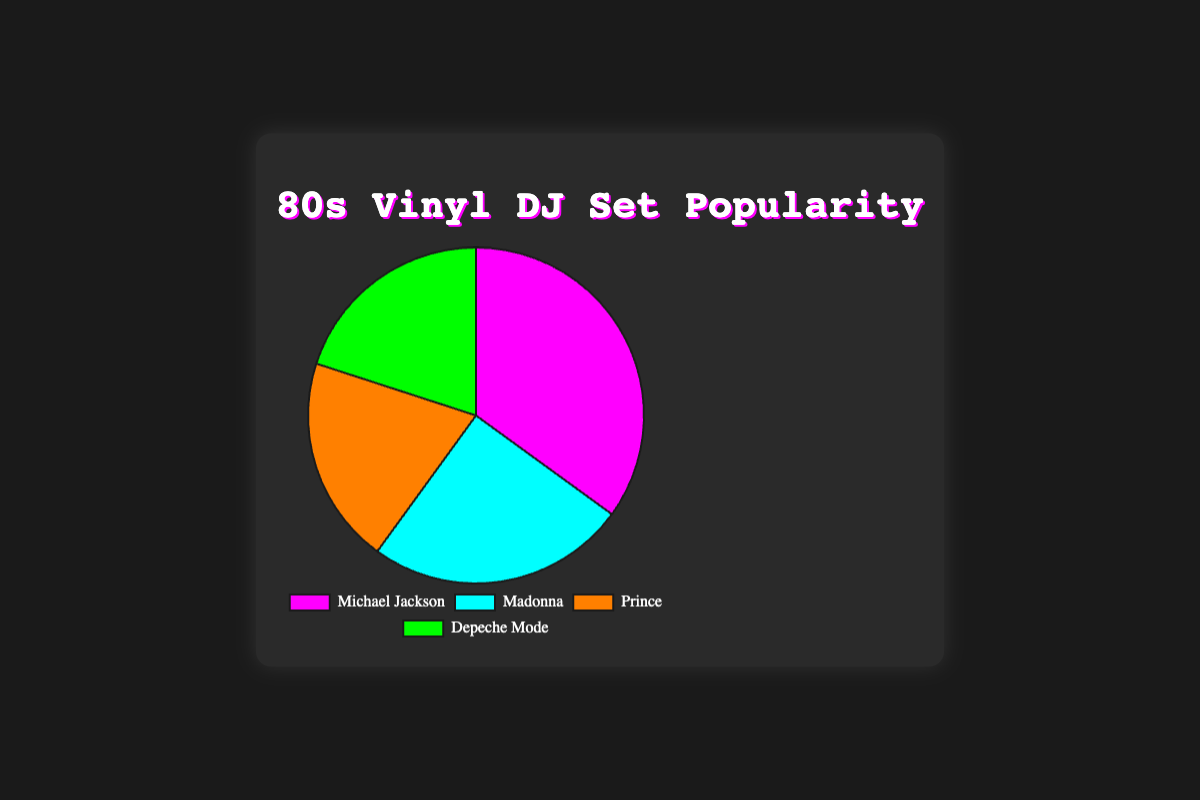Which artist appears most frequently in the DJ sets? By looking at the pie chart, Michael Jackson holds the largest section with 35 sets, which is the highest among the artists.
Answer: Michael Jackson Which artist appears least frequently in the DJ sets? Both Prince and Depeche Mode have the smallest sections in the pie chart, each with 20 sets.
Answer: Prince and Depeche Mode What is the total number of DJ sets represented in the pie chart? To get the total count, sum the sets of all artists: 35 (Michael Jackson) + 25 (Madonna) + 20 (Prince) + 20 (Depeche Mode) = 100 sets.
Answer: 100 How many more DJ sets does Michael Jackson have compared to Prince? Michael Jackson has 35 sets, and Prince has 20 sets. The difference is 35 - 20 = 15 sets.
Answer: 15 What is the average number of DJ sets per artist? The total number of sets is 100. There are 4 artists, so the average is 100 / 4 = 25 sets per artist.
Answer: 25 Which artist has a section colored in blue? By referring to the pie chart's color representation, Madonna's section is colored in blue.
Answer: Madonna How much larger is the combined proportion of Michael Jackson and Madonna compared to Prince and Depeche Mode? Michael Jackson and Madonna together have 35 + 25 = 60 sets. Prince and Depeche Mode together have 20 + 20 = 40 sets. The difference is 60 - 40 = 20 sets.
Answer: 20 What proportion of DJ sets does Depeche Mode represent out of the total? Depeche Mode has 20 sets out of the total 100 sets. The proportion is 20 / 100 = 0.2 or 20%.
Answer: 20% What color represents Prince in the pie chart? Prince is represented by the orange section of the pie chart.
Answer: Orange 